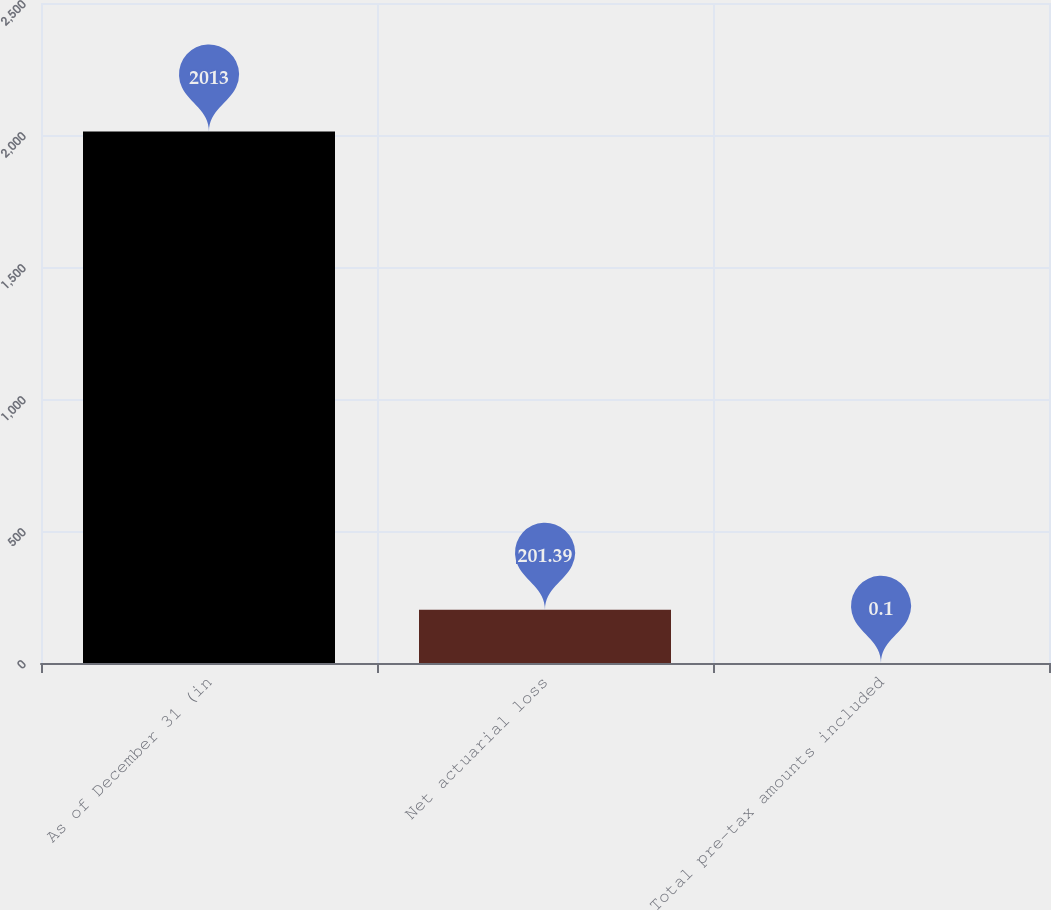Convert chart to OTSL. <chart><loc_0><loc_0><loc_500><loc_500><bar_chart><fcel>As of December 31 (in<fcel>Net actuarial loss<fcel>Total pre-tax amounts included<nl><fcel>2013<fcel>201.39<fcel>0.1<nl></chart> 